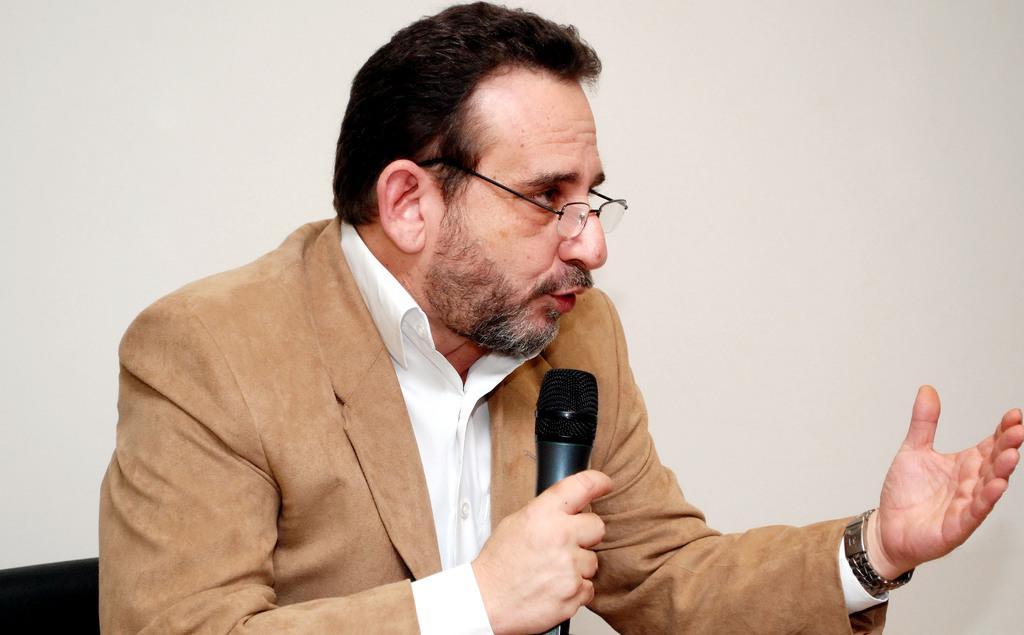Could you give a brief overview of what you see in this image? In this picture we can see a man is talking with the help of microphone. 